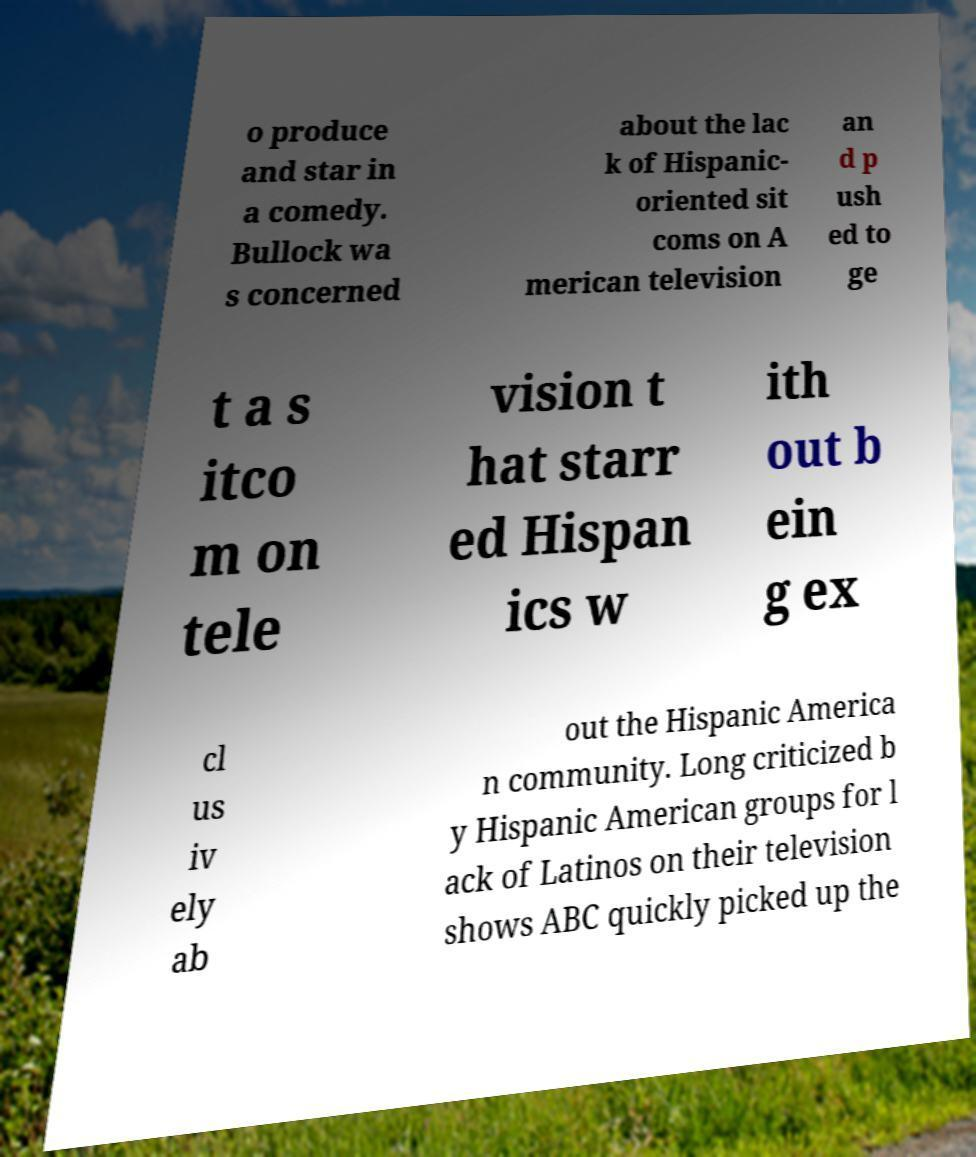For documentation purposes, I need the text within this image transcribed. Could you provide that? o produce and star in a comedy. Bullock wa s concerned about the lac k of Hispanic- oriented sit coms on A merican television an d p ush ed to ge t a s itco m on tele vision t hat starr ed Hispan ics w ith out b ein g ex cl us iv ely ab out the Hispanic America n community. Long criticized b y Hispanic American groups for l ack of Latinos on their television shows ABC quickly picked up the 